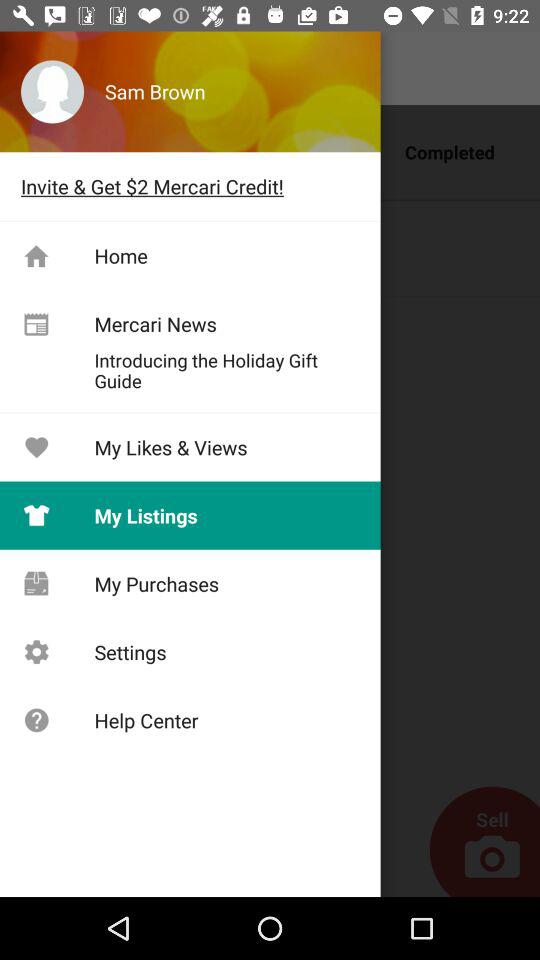Which item is selected? The selected item is "My Listings". 